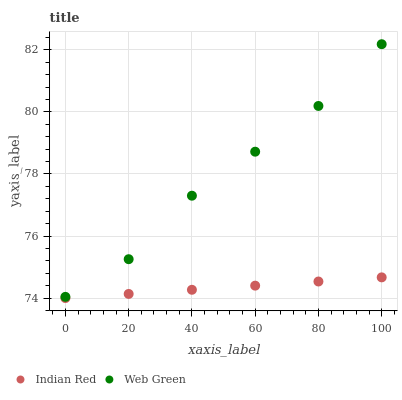Does Indian Red have the minimum area under the curve?
Answer yes or no. Yes. Does Web Green have the maximum area under the curve?
Answer yes or no. Yes. Does Indian Red have the maximum area under the curve?
Answer yes or no. No. Is Indian Red the smoothest?
Answer yes or no. Yes. Is Web Green the roughest?
Answer yes or no. Yes. Is Indian Red the roughest?
Answer yes or no. No. Does Indian Red have the lowest value?
Answer yes or no. Yes. Does Web Green have the highest value?
Answer yes or no. Yes. Does Indian Red have the highest value?
Answer yes or no. No. Is Indian Red less than Web Green?
Answer yes or no. Yes. Is Web Green greater than Indian Red?
Answer yes or no. Yes. Does Indian Red intersect Web Green?
Answer yes or no. No. 